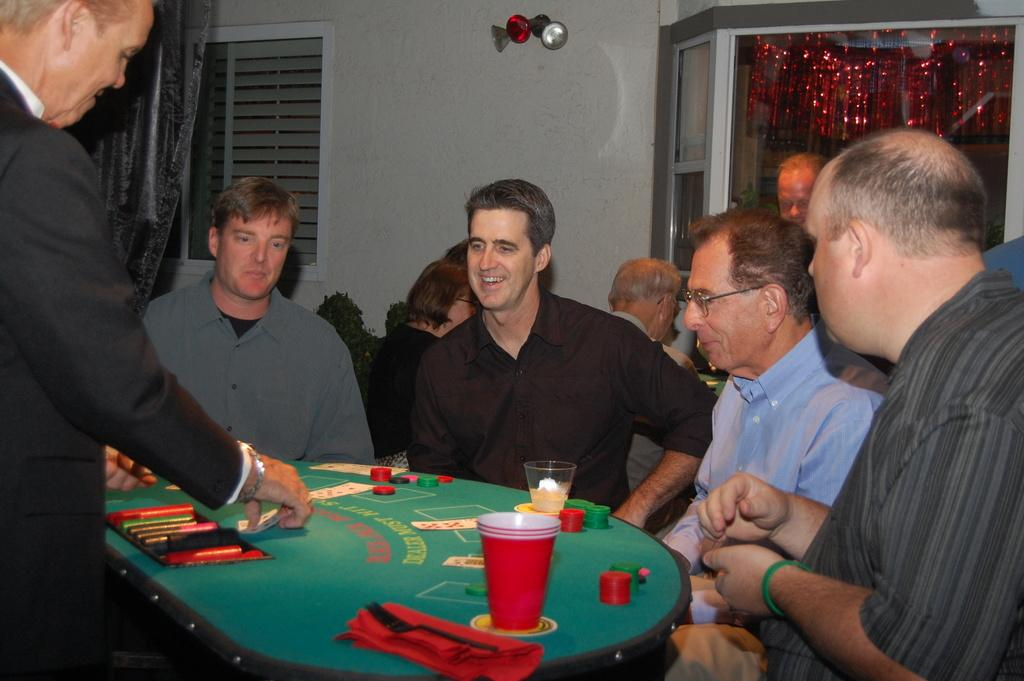How many people are present in the image? There are five people in the image. What are the people doing in the image? The people are sitting on chairs. Where are the chairs located in relation to the table? The chairs are in front of a table. What items can be seen on the table? There are glasses and coins of a game on the table. What type of oatmeal is being served in the image? There is no oatmeal present in the image. In which direction are the people facing in the image? The provided facts do not specify the direction the people are facing, so it cannot be determined from the image. 